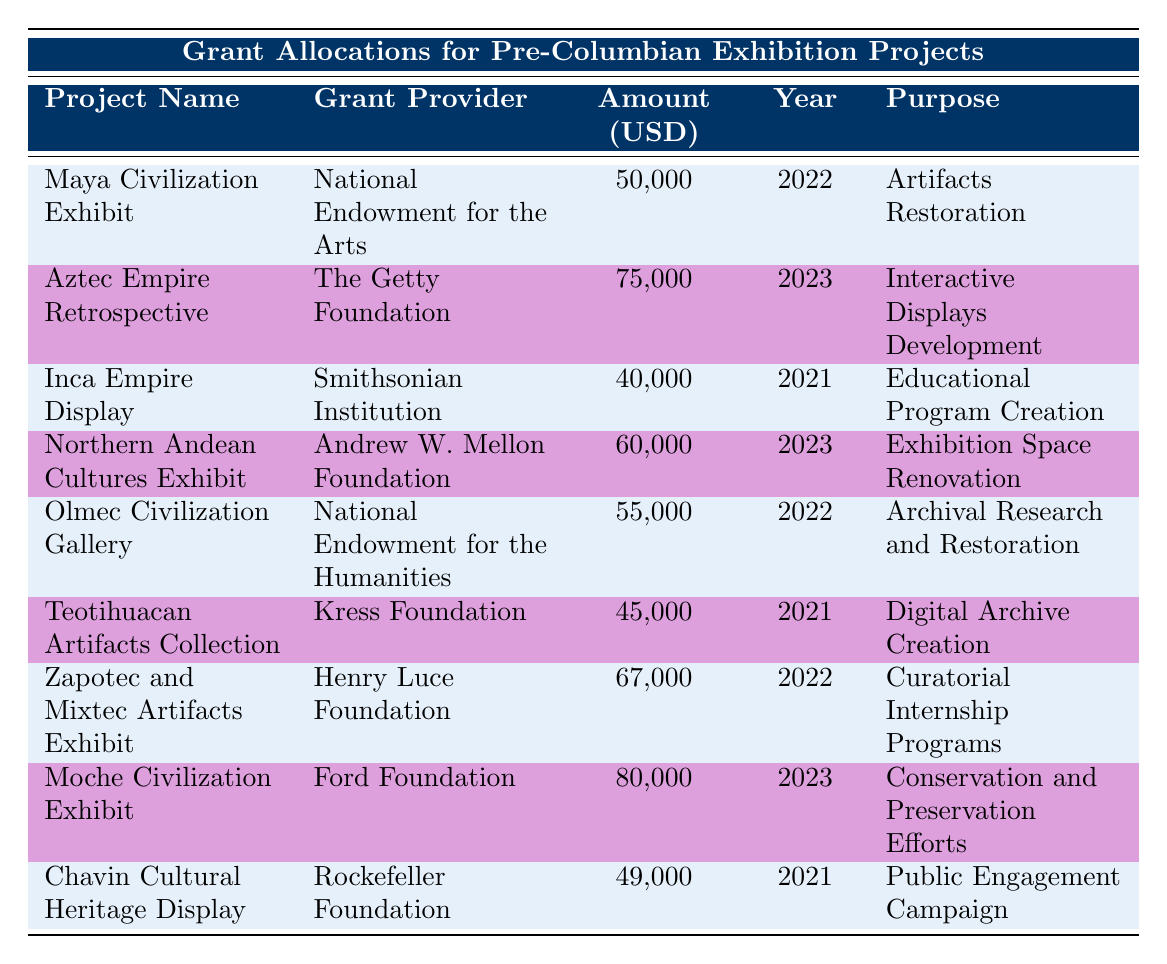What is the total allocation amount for projects in 2023? The projects in 2023 are the "Aztec Empire Retrospective," "Northern Andean Cultures Exhibit," and "Moche Civilization Exhibit." Their allocation amounts are 75,000, 60,000, and 80,000 USD respectively. The total is calculated as 75,000 + 60,000 + 80,000 = 215,000 USD.
Answer: 215,000 USD Which grant provider allocated the highest amount for a project? The project with the highest allocation is the "Moche Civilization Exhibit" funded by the Ford Foundation with 80,000 USD.
Answer: Ford Foundation Is there a project funded by the National Endowment for the Humanities? The "Olmec Civilization Gallery" is funded by the National Endowment for the Humanities.
Answer: Yes What is the difference in allocation amounts between the highest and lowest funded projects? The highest funded project is the "Moche Civilization Exhibit" with 80,000 USD, and the lowest is the "Chavin Cultural Heritage Display" with 49,000 USD. The difference is 80,000 - 49,000 = 31,000 USD.
Answer: 31,000 USD How many projects received funding for restoration purposes? The projects with funding for restoration are: "Artifacts Restoration" for the "Maya Civilization Exhibit," "Archival Research and Restoration" for the "Olmec Civilization Gallery," "Conservation and Preservation Efforts" for the "Moche Civilization Exhibit." Thus, there are 3 projects.
Answer: 3 What is the average allocation amount of projects in 2022? The projects in 2022 are the "Maya Civilization Exhibit" (50,000), "Olmec Civilization Gallery" (55,000), and "Zapotec and Mixtec Artifacts Exhibit" (67,000). Adding these gives 50,000 + 55,000 + 67,000 = 172,000 USD. Since there are 3 projects, the average is 172,000 / 3 = 57,333.33 USD.
Answer: 57,333.33 USD Did any project in 2021 receive funding for educational programs? The "Inca Empire Display" received funding for "Educational Program Creation."
Answer: Yes Which purpose for funding appears most frequently among the projects? The purposes for funding include "Artifacts Restoration" (1), "Interactive Displays Development" (1), "Educational Program Creation" (1), "Exhibition Space Renovation" (1), "Archival Research and Restoration" (1), "Digital Archive Creation" (1), "Curatorial Internship Programs" (1), "Conservation and Preservation Efforts" (1), and "Public Engagement Campaign" (1). All purposes appear once, so no purpose is repeated.
Answer: None is repeated 